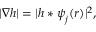Convert formula to latex. <formula><loc_0><loc_0><loc_500><loc_500>| \nabla h | = | h \ast \boldsymbol \psi _ { j } ( \boldsymbol r ) | ^ { 2 } ,</formula> 